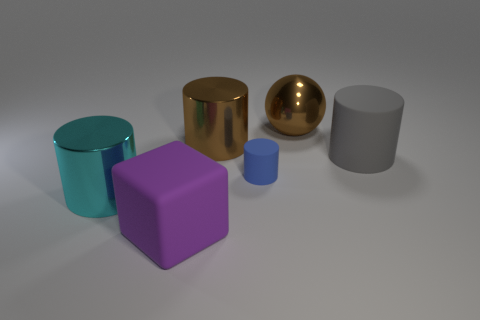Subtract 1 cylinders. How many cylinders are left? 3 Add 3 small things. How many objects exist? 9 Subtract all cylinders. How many objects are left? 2 Add 3 gray rubber balls. How many gray rubber balls exist? 3 Subtract 0 yellow cubes. How many objects are left? 6 Subtract all red balls. Subtract all brown metal balls. How many objects are left? 5 Add 4 metal cylinders. How many metal cylinders are left? 6 